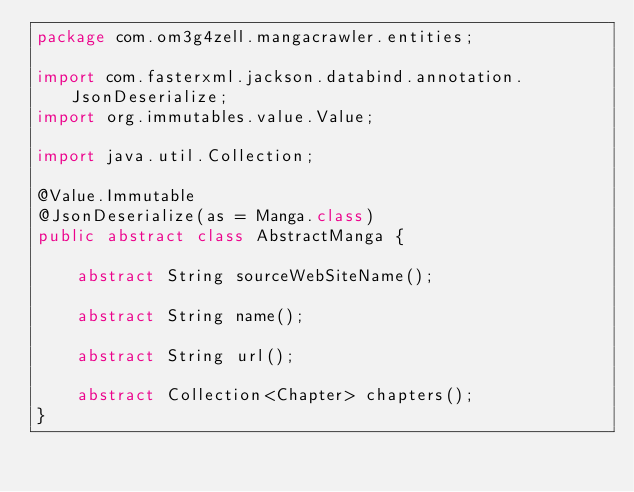Convert code to text. <code><loc_0><loc_0><loc_500><loc_500><_Java_>package com.om3g4zell.mangacrawler.entities;

import com.fasterxml.jackson.databind.annotation.JsonDeserialize;
import org.immutables.value.Value;

import java.util.Collection;

@Value.Immutable
@JsonDeserialize(as = Manga.class)
public abstract class AbstractManga {

    abstract String sourceWebSiteName();

    abstract String name();

    abstract String url();

    abstract Collection<Chapter> chapters();
}
</code> 